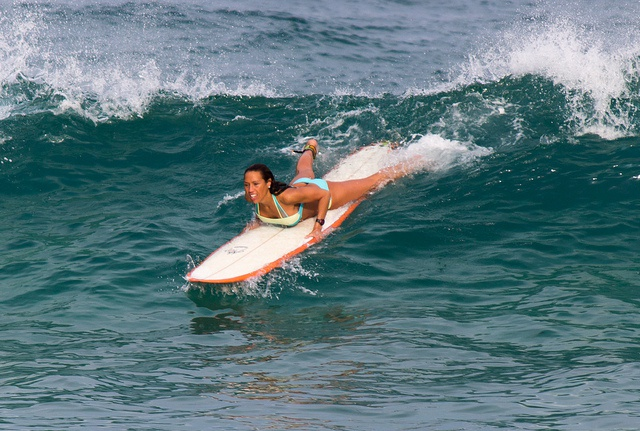Describe the objects in this image and their specific colors. I can see people in darkgray, salmon, brown, and lightpink tones and surfboard in darkgray, white, lightpink, gray, and red tones in this image. 